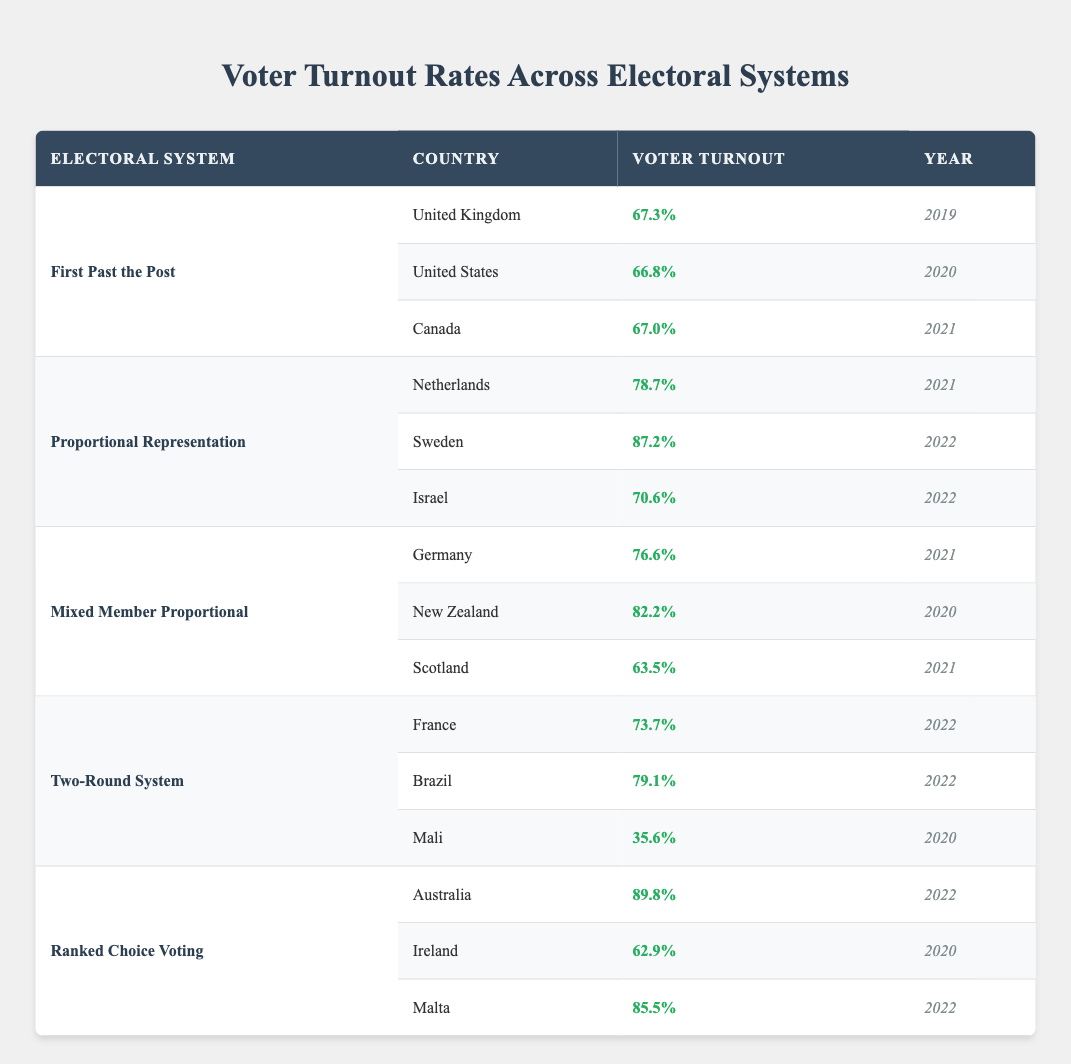What is the voter turnout percentage for the United Kingdom in 2019? The table lists the United Kingdom under the "First Past the Post" electoral system, with a reported voter turnout of 67.3% for the year 2019.
Answer: 67.3% Which country has the highest voter turnout among those using Proportional Representation? In the table, under the "Proportional Representation" system, Sweden has the highest voter turnout at 87.2% in 2022, compared to the Netherlands (78.7%) and Israel (70.6%).
Answer: Sweden What is the average voter turnout for countries using the Two-Round System? The turnout for France is 73.7%, for Brazil it is 79.1%, and for Mali it is 35.6%. To find the average, sum these values: (73.7 + 79.1 + 35.6) = 188.4. Then divide by the number of countries (3): 188.4 / 3 = 62.8.
Answer: 62.8% Did Israel have a voter turnout of over 75% in 2022? The table indicates that Israel's voter turnout in 2022 was 70.6%, which is below 75%. Therefore, the answer is no, it did not exceed 75%.
Answer: No Which electoral system has the lowest turnout recorded for a country, and what is that percentage? Reviewing the table, the lowest turnout is in Mali (35.6%) under the Two-Round System. This requires checking all countries listed to find Mali's turnout.
Answer: Two-Round System, 35.6% How does the voter turnout for New Zealand compare to that of Canada? New Zealand's voter turnout in 2020 is 82.2%, while Canada's turnout in 2021 is 67.0%. To compare, 82.2% is higher than 67.0%, making New Zealand's turnout greater overall.
Answer: New Zealand is higher What is the difference in voter turnout percentage between Australia and the United States? According to the table, Australia has a turnout of 89.8% and the United States has a turnout of 66.8%. To find the difference, subtract the United States turnout from Australia's: 89.8 - 66.8 = 23.0%.
Answer: 23.0% Is the voter turnout for Ireland greater than that for Scotland? The table shows Ireland's turnout as 62.9% and Scotland's as 63.5%. Since 62.9% is less than 63.5%, the answer is no.
Answer: No What are the turnout percentages across all electoral systems for the year 2022, and which system has the highest turnout? In 2022, the voter turnout percentages are 87.2% (Sweden), 79.1% (Brazil), 73.7% (France), and 85.5% (Malta). The highest value is 89.8% from Australia in the Ranked Choice Voting system, which is not compared here, making Ranked Choice the highest overall.
Answer: Ranked Choice Voting, 89.8% 